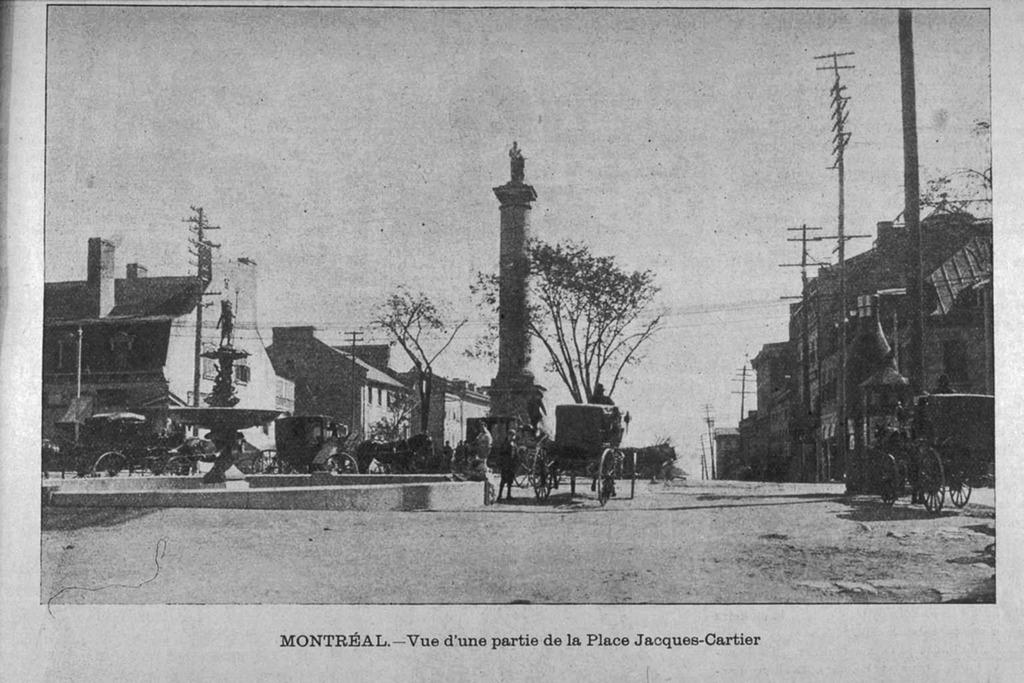What type of receipt can be seen in the image? There is no receipt present in the image. What type of pain is depicted in the image? There is no pain depicted in the image; it features include buildings, carts, a tower, electric poles, and text. Is there a cave visible in the image? There is no cave present in the image. What type of cave can be seen in the image? There is no cave present in the image. 